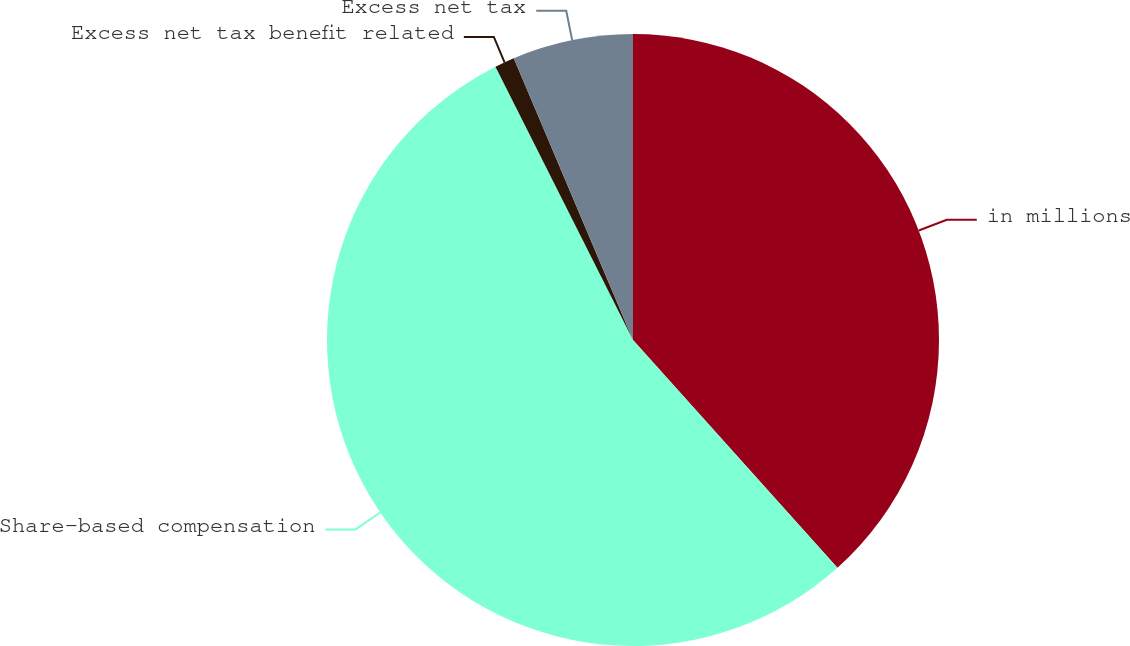<chart> <loc_0><loc_0><loc_500><loc_500><pie_chart><fcel>in millions<fcel>Share-based compensation<fcel>Excess net tax benefit related<fcel>Excess net tax<nl><fcel>38.36%<fcel>54.23%<fcel>1.05%<fcel>6.37%<nl></chart> 